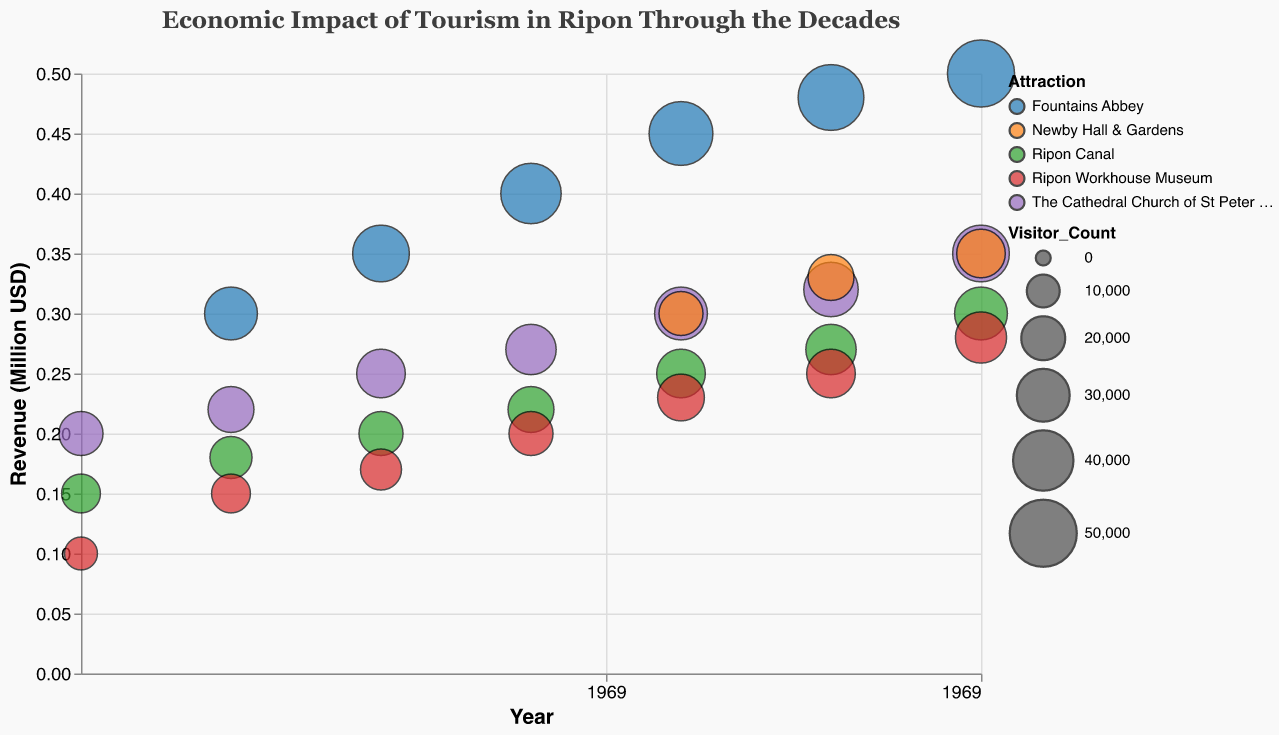What is the title of the chart? The title of the chart is the text displayed at the top, which provides an overview of the figure's content.
Answer: Economic Impact of Tourism in Ripon Through the Decades Which attraction generated the highest revenue in 2020? By looking at the chart, we see which bubble is positioned highest on the y-axis at the 2020 mark.
Answer: Fountains Abbey How has the visitor count for Ripon Canal changed from 1960 to 2020? Compare the sizes of the bubbles representing Ripon Canal over the decades. The visitor count can be inferred from the size of the bubbles.
Answer: Increased from 15,000 to 30,000 Which year had the lowest revenue for the Ripon Workhouse Museum? Look for the smallest y-axis position of the bubbles representing the Ripon Workhouse Museum.
Answer: 1960 Which two attractions were introduced after 1970? Identify the attractions that did not have any bubbles before the 1980 mark.
Answer: Fountains Abbey and Newby Hall & Gardens How does the historical significance categorize the bubbles? The tooltip data can help categorize the bubbles by their historical significance; they show as "High" or "Medium".
Answer: High and Medium Which attraction consistently shows an increase in both visitor count and revenue through the decades? Examine the bubbles for each attraction across different decades and look for a consistent upward trend in size and y-axis position.
Answer: Fountains Abbey Compare the revenue of The Cathedral Church of St Peter and St Wilfrid and Fountains Abbey in 1990. Check the y-axis positions of the bubbles for these two attractions in 1990.
Answer: The Cathedral Church of St Peter and St Wilfrid: 0.27 Million USD, Fountains Abbey: 0.4 Million USD What does a larger bubble represent in the context of this chart? The size of the bubble in this chart represents the visitor count. Larger bubbles indicate a higher visitor count.
Answer: Higher visitor count Which decade saw the introduction of Newby Hall & Gardens? Identify the first appearance of a bubble for Newby Hall & Gardens on the x-axis.
Answer: 2000 